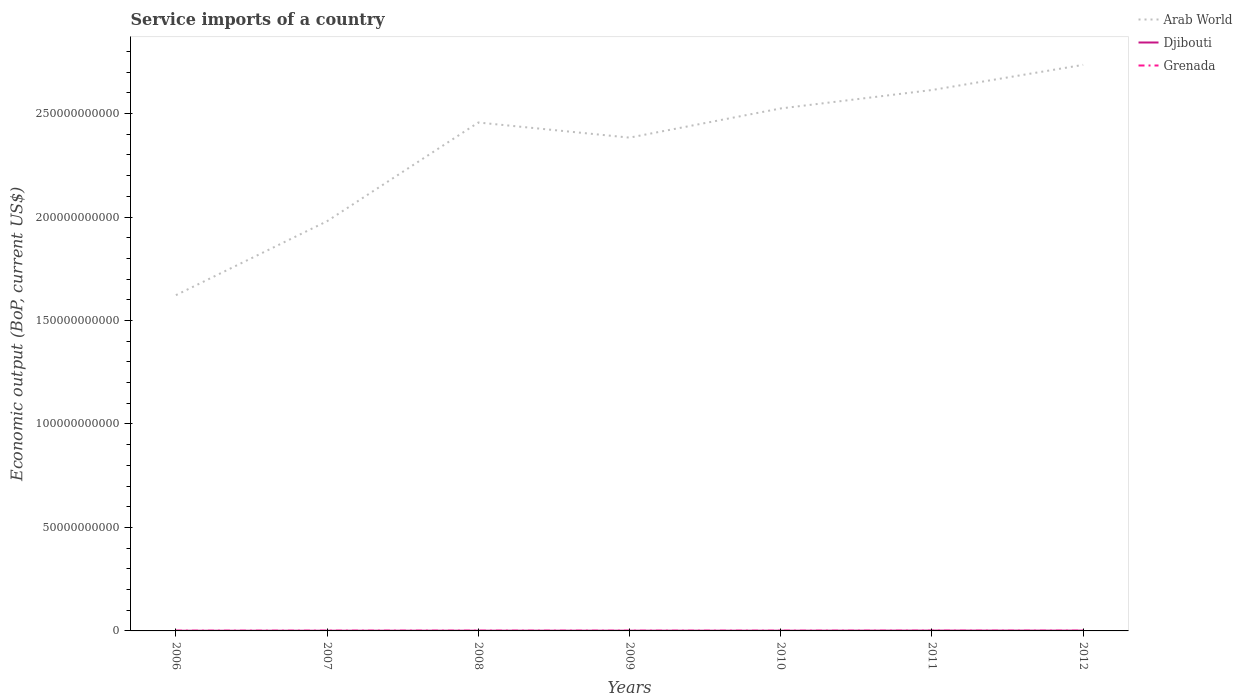Does the line corresponding to Arab World intersect with the line corresponding to Grenada?
Make the answer very short. No. Across all years, what is the maximum service imports in Arab World?
Provide a succinct answer. 1.62e+11. In which year was the service imports in Grenada maximum?
Ensure brevity in your answer.  2010. What is the total service imports in Grenada in the graph?
Keep it short and to the point. 1.04e+07. What is the difference between the highest and the second highest service imports in Grenada?
Your answer should be very brief. 1.90e+07. What is the difference between the highest and the lowest service imports in Djibouti?
Keep it short and to the point. 3. How many years are there in the graph?
Give a very brief answer. 7. Are the values on the major ticks of Y-axis written in scientific E-notation?
Give a very brief answer. No. What is the title of the graph?
Ensure brevity in your answer.  Service imports of a country. What is the label or title of the X-axis?
Offer a terse response. Years. What is the label or title of the Y-axis?
Provide a short and direct response. Economic output (BoP, current US$). What is the Economic output (BoP, current US$) in Arab World in 2006?
Your answer should be compact. 1.62e+11. What is the Economic output (BoP, current US$) of Djibouti in 2006?
Give a very brief answer. 8.93e+07. What is the Economic output (BoP, current US$) in Grenada in 2006?
Offer a terse response. 1.05e+08. What is the Economic output (BoP, current US$) in Arab World in 2007?
Make the answer very short. 1.98e+11. What is the Economic output (BoP, current US$) in Djibouti in 2007?
Make the answer very short. 9.54e+07. What is the Economic output (BoP, current US$) in Grenada in 2007?
Provide a succinct answer. 1.08e+08. What is the Economic output (BoP, current US$) of Arab World in 2008?
Your answer should be compact. 2.46e+11. What is the Economic output (BoP, current US$) in Djibouti in 2008?
Offer a very short reply. 1.17e+08. What is the Economic output (BoP, current US$) of Grenada in 2008?
Provide a succinct answer. 1.13e+08. What is the Economic output (BoP, current US$) of Arab World in 2009?
Offer a terse response. 2.38e+11. What is the Economic output (BoP, current US$) in Djibouti in 2009?
Your answer should be very brief. 1.14e+08. What is the Economic output (BoP, current US$) of Grenada in 2009?
Keep it short and to the point. 9.81e+07. What is the Economic output (BoP, current US$) of Arab World in 2010?
Provide a short and direct response. 2.52e+11. What is the Economic output (BoP, current US$) of Djibouti in 2010?
Your answer should be compact. 1.05e+08. What is the Economic output (BoP, current US$) in Grenada in 2010?
Offer a very short reply. 9.40e+07. What is the Economic output (BoP, current US$) in Arab World in 2011?
Your answer should be compact. 2.61e+11. What is the Economic output (BoP, current US$) in Djibouti in 2011?
Provide a succinct answer. 1.48e+08. What is the Economic output (BoP, current US$) in Grenada in 2011?
Offer a very short reply. 1.00e+08. What is the Economic output (BoP, current US$) in Arab World in 2012?
Your response must be concise. 2.74e+11. What is the Economic output (BoP, current US$) in Djibouti in 2012?
Make the answer very short. 1.45e+08. What is the Economic output (BoP, current US$) of Grenada in 2012?
Your answer should be compact. 9.54e+07. Across all years, what is the maximum Economic output (BoP, current US$) of Arab World?
Provide a short and direct response. 2.74e+11. Across all years, what is the maximum Economic output (BoP, current US$) in Djibouti?
Your answer should be compact. 1.48e+08. Across all years, what is the maximum Economic output (BoP, current US$) in Grenada?
Make the answer very short. 1.13e+08. Across all years, what is the minimum Economic output (BoP, current US$) in Arab World?
Offer a very short reply. 1.62e+11. Across all years, what is the minimum Economic output (BoP, current US$) in Djibouti?
Ensure brevity in your answer.  8.93e+07. Across all years, what is the minimum Economic output (BoP, current US$) in Grenada?
Make the answer very short. 9.40e+07. What is the total Economic output (BoP, current US$) in Arab World in the graph?
Make the answer very short. 1.63e+12. What is the total Economic output (BoP, current US$) in Djibouti in the graph?
Make the answer very short. 8.12e+08. What is the total Economic output (BoP, current US$) in Grenada in the graph?
Give a very brief answer. 7.14e+08. What is the difference between the Economic output (BoP, current US$) of Arab World in 2006 and that in 2007?
Keep it short and to the point. -3.57e+1. What is the difference between the Economic output (BoP, current US$) of Djibouti in 2006 and that in 2007?
Provide a succinct answer. -6.10e+06. What is the difference between the Economic output (BoP, current US$) of Grenada in 2006 and that in 2007?
Offer a terse response. -3.19e+06. What is the difference between the Economic output (BoP, current US$) of Arab World in 2006 and that in 2008?
Offer a terse response. -8.34e+1. What is the difference between the Economic output (BoP, current US$) in Djibouti in 2006 and that in 2008?
Your response must be concise. -2.72e+07. What is the difference between the Economic output (BoP, current US$) in Grenada in 2006 and that in 2008?
Give a very brief answer. -7.66e+06. What is the difference between the Economic output (BoP, current US$) in Arab World in 2006 and that in 2009?
Your response must be concise. -7.61e+1. What is the difference between the Economic output (BoP, current US$) in Djibouti in 2006 and that in 2009?
Keep it short and to the point. -2.47e+07. What is the difference between the Economic output (BoP, current US$) in Grenada in 2006 and that in 2009?
Provide a succinct answer. 7.21e+06. What is the difference between the Economic output (BoP, current US$) of Arab World in 2006 and that in 2010?
Give a very brief answer. -9.02e+1. What is the difference between the Economic output (BoP, current US$) in Djibouti in 2006 and that in 2010?
Offer a very short reply. -1.53e+07. What is the difference between the Economic output (BoP, current US$) in Grenada in 2006 and that in 2010?
Offer a very short reply. 1.13e+07. What is the difference between the Economic output (BoP, current US$) of Arab World in 2006 and that in 2011?
Ensure brevity in your answer.  -9.91e+1. What is the difference between the Economic output (BoP, current US$) of Djibouti in 2006 and that in 2011?
Make the answer very short. -5.85e+07. What is the difference between the Economic output (BoP, current US$) of Grenada in 2006 and that in 2011?
Make the answer very short. 5.11e+06. What is the difference between the Economic output (BoP, current US$) of Arab World in 2006 and that in 2012?
Your response must be concise. -1.11e+11. What is the difference between the Economic output (BoP, current US$) in Djibouti in 2006 and that in 2012?
Provide a succinct answer. -5.53e+07. What is the difference between the Economic output (BoP, current US$) of Grenada in 2006 and that in 2012?
Offer a very short reply. 9.94e+06. What is the difference between the Economic output (BoP, current US$) in Arab World in 2007 and that in 2008?
Your answer should be very brief. -4.77e+1. What is the difference between the Economic output (BoP, current US$) in Djibouti in 2007 and that in 2008?
Your answer should be very brief. -2.11e+07. What is the difference between the Economic output (BoP, current US$) of Grenada in 2007 and that in 2008?
Provide a succinct answer. -4.47e+06. What is the difference between the Economic output (BoP, current US$) in Arab World in 2007 and that in 2009?
Give a very brief answer. -4.04e+1. What is the difference between the Economic output (BoP, current US$) in Djibouti in 2007 and that in 2009?
Your answer should be compact. -1.86e+07. What is the difference between the Economic output (BoP, current US$) in Grenada in 2007 and that in 2009?
Your answer should be compact. 1.04e+07. What is the difference between the Economic output (BoP, current US$) in Arab World in 2007 and that in 2010?
Offer a terse response. -5.45e+1. What is the difference between the Economic output (BoP, current US$) of Djibouti in 2007 and that in 2010?
Offer a terse response. -9.17e+06. What is the difference between the Economic output (BoP, current US$) of Grenada in 2007 and that in 2010?
Offer a very short reply. 1.45e+07. What is the difference between the Economic output (BoP, current US$) of Arab World in 2007 and that in 2011?
Your answer should be very brief. -6.34e+1. What is the difference between the Economic output (BoP, current US$) in Djibouti in 2007 and that in 2011?
Your answer should be compact. -5.24e+07. What is the difference between the Economic output (BoP, current US$) of Grenada in 2007 and that in 2011?
Give a very brief answer. 8.30e+06. What is the difference between the Economic output (BoP, current US$) in Arab World in 2007 and that in 2012?
Your answer should be very brief. -7.55e+1. What is the difference between the Economic output (BoP, current US$) of Djibouti in 2007 and that in 2012?
Give a very brief answer. -4.92e+07. What is the difference between the Economic output (BoP, current US$) in Grenada in 2007 and that in 2012?
Ensure brevity in your answer.  1.31e+07. What is the difference between the Economic output (BoP, current US$) in Arab World in 2008 and that in 2009?
Your response must be concise. 7.30e+09. What is the difference between the Economic output (BoP, current US$) of Djibouti in 2008 and that in 2009?
Provide a short and direct response. 2.54e+06. What is the difference between the Economic output (BoP, current US$) in Grenada in 2008 and that in 2009?
Offer a terse response. 1.49e+07. What is the difference between the Economic output (BoP, current US$) in Arab World in 2008 and that in 2010?
Offer a very short reply. -6.80e+09. What is the difference between the Economic output (BoP, current US$) in Djibouti in 2008 and that in 2010?
Keep it short and to the point. 1.20e+07. What is the difference between the Economic output (BoP, current US$) in Grenada in 2008 and that in 2010?
Your answer should be compact. 1.90e+07. What is the difference between the Economic output (BoP, current US$) in Arab World in 2008 and that in 2011?
Keep it short and to the point. -1.57e+1. What is the difference between the Economic output (BoP, current US$) in Djibouti in 2008 and that in 2011?
Your answer should be very brief. -3.13e+07. What is the difference between the Economic output (BoP, current US$) of Grenada in 2008 and that in 2011?
Provide a short and direct response. 1.28e+07. What is the difference between the Economic output (BoP, current US$) of Arab World in 2008 and that in 2012?
Give a very brief answer. -2.79e+1. What is the difference between the Economic output (BoP, current US$) in Djibouti in 2008 and that in 2012?
Your answer should be compact. -2.81e+07. What is the difference between the Economic output (BoP, current US$) in Grenada in 2008 and that in 2012?
Your response must be concise. 1.76e+07. What is the difference between the Economic output (BoP, current US$) of Arab World in 2009 and that in 2010?
Offer a very short reply. -1.41e+1. What is the difference between the Economic output (BoP, current US$) of Djibouti in 2009 and that in 2010?
Ensure brevity in your answer.  9.42e+06. What is the difference between the Economic output (BoP, current US$) in Grenada in 2009 and that in 2010?
Give a very brief answer. 4.11e+06. What is the difference between the Economic output (BoP, current US$) in Arab World in 2009 and that in 2011?
Provide a succinct answer. -2.30e+1. What is the difference between the Economic output (BoP, current US$) of Djibouti in 2009 and that in 2011?
Ensure brevity in your answer.  -3.38e+07. What is the difference between the Economic output (BoP, current US$) of Grenada in 2009 and that in 2011?
Your answer should be compact. -2.10e+06. What is the difference between the Economic output (BoP, current US$) in Arab World in 2009 and that in 2012?
Your answer should be very brief. -3.52e+1. What is the difference between the Economic output (BoP, current US$) in Djibouti in 2009 and that in 2012?
Provide a succinct answer. -3.06e+07. What is the difference between the Economic output (BoP, current US$) of Grenada in 2009 and that in 2012?
Offer a terse response. 2.73e+06. What is the difference between the Economic output (BoP, current US$) in Arab World in 2010 and that in 2011?
Your answer should be compact. -8.90e+09. What is the difference between the Economic output (BoP, current US$) in Djibouti in 2010 and that in 2011?
Provide a succinct answer. -4.32e+07. What is the difference between the Economic output (BoP, current US$) in Grenada in 2010 and that in 2011?
Make the answer very short. -6.20e+06. What is the difference between the Economic output (BoP, current US$) in Arab World in 2010 and that in 2012?
Ensure brevity in your answer.  -2.11e+1. What is the difference between the Economic output (BoP, current US$) of Djibouti in 2010 and that in 2012?
Offer a terse response. -4.01e+07. What is the difference between the Economic output (BoP, current US$) of Grenada in 2010 and that in 2012?
Offer a terse response. -1.37e+06. What is the difference between the Economic output (BoP, current US$) of Arab World in 2011 and that in 2012?
Provide a short and direct response. -1.22e+1. What is the difference between the Economic output (BoP, current US$) of Djibouti in 2011 and that in 2012?
Your answer should be compact. 3.16e+06. What is the difference between the Economic output (BoP, current US$) in Grenada in 2011 and that in 2012?
Give a very brief answer. 4.83e+06. What is the difference between the Economic output (BoP, current US$) of Arab World in 2006 and the Economic output (BoP, current US$) of Djibouti in 2007?
Ensure brevity in your answer.  1.62e+11. What is the difference between the Economic output (BoP, current US$) of Arab World in 2006 and the Economic output (BoP, current US$) of Grenada in 2007?
Offer a very short reply. 1.62e+11. What is the difference between the Economic output (BoP, current US$) of Djibouti in 2006 and the Economic output (BoP, current US$) of Grenada in 2007?
Give a very brief answer. -1.92e+07. What is the difference between the Economic output (BoP, current US$) in Arab World in 2006 and the Economic output (BoP, current US$) in Djibouti in 2008?
Give a very brief answer. 1.62e+11. What is the difference between the Economic output (BoP, current US$) of Arab World in 2006 and the Economic output (BoP, current US$) of Grenada in 2008?
Offer a terse response. 1.62e+11. What is the difference between the Economic output (BoP, current US$) in Djibouti in 2006 and the Economic output (BoP, current US$) in Grenada in 2008?
Make the answer very short. -2.37e+07. What is the difference between the Economic output (BoP, current US$) of Arab World in 2006 and the Economic output (BoP, current US$) of Djibouti in 2009?
Keep it short and to the point. 1.62e+11. What is the difference between the Economic output (BoP, current US$) of Arab World in 2006 and the Economic output (BoP, current US$) of Grenada in 2009?
Provide a succinct answer. 1.62e+11. What is the difference between the Economic output (BoP, current US$) in Djibouti in 2006 and the Economic output (BoP, current US$) in Grenada in 2009?
Your answer should be compact. -8.83e+06. What is the difference between the Economic output (BoP, current US$) of Arab World in 2006 and the Economic output (BoP, current US$) of Djibouti in 2010?
Offer a terse response. 1.62e+11. What is the difference between the Economic output (BoP, current US$) of Arab World in 2006 and the Economic output (BoP, current US$) of Grenada in 2010?
Offer a very short reply. 1.62e+11. What is the difference between the Economic output (BoP, current US$) in Djibouti in 2006 and the Economic output (BoP, current US$) in Grenada in 2010?
Your response must be concise. -4.73e+06. What is the difference between the Economic output (BoP, current US$) in Arab World in 2006 and the Economic output (BoP, current US$) in Djibouti in 2011?
Offer a very short reply. 1.62e+11. What is the difference between the Economic output (BoP, current US$) in Arab World in 2006 and the Economic output (BoP, current US$) in Grenada in 2011?
Your answer should be very brief. 1.62e+11. What is the difference between the Economic output (BoP, current US$) of Djibouti in 2006 and the Economic output (BoP, current US$) of Grenada in 2011?
Your answer should be compact. -1.09e+07. What is the difference between the Economic output (BoP, current US$) in Arab World in 2006 and the Economic output (BoP, current US$) in Djibouti in 2012?
Keep it short and to the point. 1.62e+11. What is the difference between the Economic output (BoP, current US$) in Arab World in 2006 and the Economic output (BoP, current US$) in Grenada in 2012?
Ensure brevity in your answer.  1.62e+11. What is the difference between the Economic output (BoP, current US$) in Djibouti in 2006 and the Economic output (BoP, current US$) in Grenada in 2012?
Your response must be concise. -6.10e+06. What is the difference between the Economic output (BoP, current US$) of Arab World in 2007 and the Economic output (BoP, current US$) of Djibouti in 2008?
Your answer should be very brief. 1.98e+11. What is the difference between the Economic output (BoP, current US$) in Arab World in 2007 and the Economic output (BoP, current US$) in Grenada in 2008?
Your answer should be very brief. 1.98e+11. What is the difference between the Economic output (BoP, current US$) of Djibouti in 2007 and the Economic output (BoP, current US$) of Grenada in 2008?
Provide a short and direct response. -1.76e+07. What is the difference between the Economic output (BoP, current US$) in Arab World in 2007 and the Economic output (BoP, current US$) in Djibouti in 2009?
Give a very brief answer. 1.98e+11. What is the difference between the Economic output (BoP, current US$) of Arab World in 2007 and the Economic output (BoP, current US$) of Grenada in 2009?
Provide a short and direct response. 1.98e+11. What is the difference between the Economic output (BoP, current US$) of Djibouti in 2007 and the Economic output (BoP, current US$) of Grenada in 2009?
Your answer should be compact. -2.73e+06. What is the difference between the Economic output (BoP, current US$) of Arab World in 2007 and the Economic output (BoP, current US$) of Djibouti in 2010?
Your answer should be very brief. 1.98e+11. What is the difference between the Economic output (BoP, current US$) in Arab World in 2007 and the Economic output (BoP, current US$) in Grenada in 2010?
Your response must be concise. 1.98e+11. What is the difference between the Economic output (BoP, current US$) of Djibouti in 2007 and the Economic output (BoP, current US$) of Grenada in 2010?
Make the answer very short. 1.37e+06. What is the difference between the Economic output (BoP, current US$) of Arab World in 2007 and the Economic output (BoP, current US$) of Djibouti in 2011?
Provide a succinct answer. 1.98e+11. What is the difference between the Economic output (BoP, current US$) in Arab World in 2007 and the Economic output (BoP, current US$) in Grenada in 2011?
Give a very brief answer. 1.98e+11. What is the difference between the Economic output (BoP, current US$) in Djibouti in 2007 and the Economic output (BoP, current US$) in Grenada in 2011?
Your response must be concise. -4.83e+06. What is the difference between the Economic output (BoP, current US$) in Arab World in 2007 and the Economic output (BoP, current US$) in Djibouti in 2012?
Your answer should be compact. 1.98e+11. What is the difference between the Economic output (BoP, current US$) of Arab World in 2007 and the Economic output (BoP, current US$) of Grenada in 2012?
Provide a short and direct response. 1.98e+11. What is the difference between the Economic output (BoP, current US$) in Djibouti in 2007 and the Economic output (BoP, current US$) in Grenada in 2012?
Ensure brevity in your answer.  -445.55. What is the difference between the Economic output (BoP, current US$) of Arab World in 2008 and the Economic output (BoP, current US$) of Djibouti in 2009?
Offer a terse response. 2.46e+11. What is the difference between the Economic output (BoP, current US$) in Arab World in 2008 and the Economic output (BoP, current US$) in Grenada in 2009?
Offer a terse response. 2.46e+11. What is the difference between the Economic output (BoP, current US$) of Djibouti in 2008 and the Economic output (BoP, current US$) of Grenada in 2009?
Offer a very short reply. 1.84e+07. What is the difference between the Economic output (BoP, current US$) of Arab World in 2008 and the Economic output (BoP, current US$) of Djibouti in 2010?
Make the answer very short. 2.46e+11. What is the difference between the Economic output (BoP, current US$) of Arab World in 2008 and the Economic output (BoP, current US$) of Grenada in 2010?
Offer a terse response. 2.46e+11. What is the difference between the Economic output (BoP, current US$) of Djibouti in 2008 and the Economic output (BoP, current US$) of Grenada in 2010?
Your answer should be compact. 2.25e+07. What is the difference between the Economic output (BoP, current US$) of Arab World in 2008 and the Economic output (BoP, current US$) of Djibouti in 2011?
Your answer should be compact. 2.46e+11. What is the difference between the Economic output (BoP, current US$) in Arab World in 2008 and the Economic output (BoP, current US$) in Grenada in 2011?
Offer a terse response. 2.46e+11. What is the difference between the Economic output (BoP, current US$) of Djibouti in 2008 and the Economic output (BoP, current US$) of Grenada in 2011?
Ensure brevity in your answer.  1.63e+07. What is the difference between the Economic output (BoP, current US$) in Arab World in 2008 and the Economic output (BoP, current US$) in Djibouti in 2012?
Offer a very short reply. 2.46e+11. What is the difference between the Economic output (BoP, current US$) of Arab World in 2008 and the Economic output (BoP, current US$) of Grenada in 2012?
Your answer should be very brief. 2.46e+11. What is the difference between the Economic output (BoP, current US$) in Djibouti in 2008 and the Economic output (BoP, current US$) in Grenada in 2012?
Your answer should be very brief. 2.11e+07. What is the difference between the Economic output (BoP, current US$) of Arab World in 2009 and the Economic output (BoP, current US$) of Djibouti in 2010?
Provide a succinct answer. 2.38e+11. What is the difference between the Economic output (BoP, current US$) in Arab World in 2009 and the Economic output (BoP, current US$) in Grenada in 2010?
Your answer should be compact. 2.38e+11. What is the difference between the Economic output (BoP, current US$) in Djibouti in 2009 and the Economic output (BoP, current US$) in Grenada in 2010?
Give a very brief answer. 2.00e+07. What is the difference between the Economic output (BoP, current US$) of Arab World in 2009 and the Economic output (BoP, current US$) of Djibouti in 2011?
Make the answer very short. 2.38e+11. What is the difference between the Economic output (BoP, current US$) of Arab World in 2009 and the Economic output (BoP, current US$) of Grenada in 2011?
Provide a succinct answer. 2.38e+11. What is the difference between the Economic output (BoP, current US$) in Djibouti in 2009 and the Economic output (BoP, current US$) in Grenada in 2011?
Your answer should be compact. 1.38e+07. What is the difference between the Economic output (BoP, current US$) in Arab World in 2009 and the Economic output (BoP, current US$) in Djibouti in 2012?
Keep it short and to the point. 2.38e+11. What is the difference between the Economic output (BoP, current US$) in Arab World in 2009 and the Economic output (BoP, current US$) in Grenada in 2012?
Your answer should be compact. 2.38e+11. What is the difference between the Economic output (BoP, current US$) in Djibouti in 2009 and the Economic output (BoP, current US$) in Grenada in 2012?
Offer a very short reply. 1.86e+07. What is the difference between the Economic output (BoP, current US$) in Arab World in 2010 and the Economic output (BoP, current US$) in Djibouti in 2011?
Your response must be concise. 2.52e+11. What is the difference between the Economic output (BoP, current US$) of Arab World in 2010 and the Economic output (BoP, current US$) of Grenada in 2011?
Offer a very short reply. 2.52e+11. What is the difference between the Economic output (BoP, current US$) of Djibouti in 2010 and the Economic output (BoP, current US$) of Grenada in 2011?
Provide a succinct answer. 4.34e+06. What is the difference between the Economic output (BoP, current US$) of Arab World in 2010 and the Economic output (BoP, current US$) of Djibouti in 2012?
Provide a short and direct response. 2.52e+11. What is the difference between the Economic output (BoP, current US$) in Arab World in 2010 and the Economic output (BoP, current US$) in Grenada in 2012?
Your response must be concise. 2.52e+11. What is the difference between the Economic output (BoP, current US$) of Djibouti in 2010 and the Economic output (BoP, current US$) of Grenada in 2012?
Your response must be concise. 9.17e+06. What is the difference between the Economic output (BoP, current US$) of Arab World in 2011 and the Economic output (BoP, current US$) of Djibouti in 2012?
Keep it short and to the point. 2.61e+11. What is the difference between the Economic output (BoP, current US$) in Arab World in 2011 and the Economic output (BoP, current US$) in Grenada in 2012?
Ensure brevity in your answer.  2.61e+11. What is the difference between the Economic output (BoP, current US$) of Djibouti in 2011 and the Economic output (BoP, current US$) of Grenada in 2012?
Ensure brevity in your answer.  5.24e+07. What is the average Economic output (BoP, current US$) in Arab World per year?
Offer a terse response. 2.33e+11. What is the average Economic output (BoP, current US$) in Djibouti per year?
Offer a terse response. 1.16e+08. What is the average Economic output (BoP, current US$) in Grenada per year?
Your answer should be very brief. 1.02e+08. In the year 2006, what is the difference between the Economic output (BoP, current US$) in Arab World and Economic output (BoP, current US$) in Djibouti?
Give a very brief answer. 1.62e+11. In the year 2006, what is the difference between the Economic output (BoP, current US$) of Arab World and Economic output (BoP, current US$) of Grenada?
Offer a very short reply. 1.62e+11. In the year 2006, what is the difference between the Economic output (BoP, current US$) in Djibouti and Economic output (BoP, current US$) in Grenada?
Ensure brevity in your answer.  -1.60e+07. In the year 2007, what is the difference between the Economic output (BoP, current US$) of Arab World and Economic output (BoP, current US$) of Djibouti?
Offer a terse response. 1.98e+11. In the year 2007, what is the difference between the Economic output (BoP, current US$) in Arab World and Economic output (BoP, current US$) in Grenada?
Provide a short and direct response. 1.98e+11. In the year 2007, what is the difference between the Economic output (BoP, current US$) of Djibouti and Economic output (BoP, current US$) of Grenada?
Provide a short and direct response. -1.31e+07. In the year 2008, what is the difference between the Economic output (BoP, current US$) in Arab World and Economic output (BoP, current US$) in Djibouti?
Provide a short and direct response. 2.46e+11. In the year 2008, what is the difference between the Economic output (BoP, current US$) in Arab World and Economic output (BoP, current US$) in Grenada?
Your answer should be very brief. 2.46e+11. In the year 2008, what is the difference between the Economic output (BoP, current US$) in Djibouti and Economic output (BoP, current US$) in Grenada?
Give a very brief answer. 3.54e+06. In the year 2009, what is the difference between the Economic output (BoP, current US$) of Arab World and Economic output (BoP, current US$) of Djibouti?
Give a very brief answer. 2.38e+11. In the year 2009, what is the difference between the Economic output (BoP, current US$) of Arab World and Economic output (BoP, current US$) of Grenada?
Your response must be concise. 2.38e+11. In the year 2009, what is the difference between the Economic output (BoP, current US$) in Djibouti and Economic output (BoP, current US$) in Grenada?
Make the answer very short. 1.59e+07. In the year 2010, what is the difference between the Economic output (BoP, current US$) of Arab World and Economic output (BoP, current US$) of Djibouti?
Your answer should be compact. 2.52e+11. In the year 2010, what is the difference between the Economic output (BoP, current US$) in Arab World and Economic output (BoP, current US$) in Grenada?
Offer a terse response. 2.52e+11. In the year 2010, what is the difference between the Economic output (BoP, current US$) of Djibouti and Economic output (BoP, current US$) of Grenada?
Offer a very short reply. 1.05e+07. In the year 2011, what is the difference between the Economic output (BoP, current US$) in Arab World and Economic output (BoP, current US$) in Djibouti?
Ensure brevity in your answer.  2.61e+11. In the year 2011, what is the difference between the Economic output (BoP, current US$) of Arab World and Economic output (BoP, current US$) of Grenada?
Your answer should be compact. 2.61e+11. In the year 2011, what is the difference between the Economic output (BoP, current US$) of Djibouti and Economic output (BoP, current US$) of Grenada?
Offer a very short reply. 4.76e+07. In the year 2012, what is the difference between the Economic output (BoP, current US$) in Arab World and Economic output (BoP, current US$) in Djibouti?
Keep it short and to the point. 2.73e+11. In the year 2012, what is the difference between the Economic output (BoP, current US$) in Arab World and Economic output (BoP, current US$) in Grenada?
Your answer should be compact. 2.73e+11. In the year 2012, what is the difference between the Economic output (BoP, current US$) of Djibouti and Economic output (BoP, current US$) of Grenada?
Your answer should be very brief. 4.92e+07. What is the ratio of the Economic output (BoP, current US$) in Arab World in 2006 to that in 2007?
Your response must be concise. 0.82. What is the ratio of the Economic output (BoP, current US$) of Djibouti in 2006 to that in 2007?
Ensure brevity in your answer.  0.94. What is the ratio of the Economic output (BoP, current US$) of Grenada in 2006 to that in 2007?
Give a very brief answer. 0.97. What is the ratio of the Economic output (BoP, current US$) of Arab World in 2006 to that in 2008?
Keep it short and to the point. 0.66. What is the ratio of the Economic output (BoP, current US$) of Djibouti in 2006 to that in 2008?
Provide a succinct answer. 0.77. What is the ratio of the Economic output (BoP, current US$) of Grenada in 2006 to that in 2008?
Your response must be concise. 0.93. What is the ratio of the Economic output (BoP, current US$) of Arab World in 2006 to that in 2009?
Your response must be concise. 0.68. What is the ratio of the Economic output (BoP, current US$) in Djibouti in 2006 to that in 2009?
Your answer should be very brief. 0.78. What is the ratio of the Economic output (BoP, current US$) of Grenada in 2006 to that in 2009?
Ensure brevity in your answer.  1.07. What is the ratio of the Economic output (BoP, current US$) in Arab World in 2006 to that in 2010?
Ensure brevity in your answer.  0.64. What is the ratio of the Economic output (BoP, current US$) of Djibouti in 2006 to that in 2010?
Offer a terse response. 0.85. What is the ratio of the Economic output (BoP, current US$) of Grenada in 2006 to that in 2010?
Give a very brief answer. 1.12. What is the ratio of the Economic output (BoP, current US$) of Arab World in 2006 to that in 2011?
Keep it short and to the point. 0.62. What is the ratio of the Economic output (BoP, current US$) of Djibouti in 2006 to that in 2011?
Ensure brevity in your answer.  0.6. What is the ratio of the Economic output (BoP, current US$) in Grenada in 2006 to that in 2011?
Give a very brief answer. 1.05. What is the ratio of the Economic output (BoP, current US$) of Arab World in 2006 to that in 2012?
Your response must be concise. 0.59. What is the ratio of the Economic output (BoP, current US$) in Djibouti in 2006 to that in 2012?
Your answer should be compact. 0.62. What is the ratio of the Economic output (BoP, current US$) of Grenada in 2006 to that in 2012?
Your response must be concise. 1.1. What is the ratio of the Economic output (BoP, current US$) in Arab World in 2007 to that in 2008?
Keep it short and to the point. 0.81. What is the ratio of the Economic output (BoP, current US$) in Djibouti in 2007 to that in 2008?
Your answer should be compact. 0.82. What is the ratio of the Economic output (BoP, current US$) in Grenada in 2007 to that in 2008?
Your answer should be very brief. 0.96. What is the ratio of the Economic output (BoP, current US$) of Arab World in 2007 to that in 2009?
Offer a very short reply. 0.83. What is the ratio of the Economic output (BoP, current US$) in Djibouti in 2007 to that in 2009?
Provide a short and direct response. 0.84. What is the ratio of the Economic output (BoP, current US$) of Grenada in 2007 to that in 2009?
Your answer should be very brief. 1.11. What is the ratio of the Economic output (BoP, current US$) in Arab World in 2007 to that in 2010?
Your answer should be compact. 0.78. What is the ratio of the Economic output (BoP, current US$) of Djibouti in 2007 to that in 2010?
Your answer should be very brief. 0.91. What is the ratio of the Economic output (BoP, current US$) of Grenada in 2007 to that in 2010?
Provide a succinct answer. 1.15. What is the ratio of the Economic output (BoP, current US$) in Arab World in 2007 to that in 2011?
Provide a succinct answer. 0.76. What is the ratio of the Economic output (BoP, current US$) of Djibouti in 2007 to that in 2011?
Offer a terse response. 0.65. What is the ratio of the Economic output (BoP, current US$) in Grenada in 2007 to that in 2011?
Your response must be concise. 1.08. What is the ratio of the Economic output (BoP, current US$) in Arab World in 2007 to that in 2012?
Offer a terse response. 0.72. What is the ratio of the Economic output (BoP, current US$) in Djibouti in 2007 to that in 2012?
Keep it short and to the point. 0.66. What is the ratio of the Economic output (BoP, current US$) in Grenada in 2007 to that in 2012?
Provide a succinct answer. 1.14. What is the ratio of the Economic output (BoP, current US$) in Arab World in 2008 to that in 2009?
Offer a terse response. 1.03. What is the ratio of the Economic output (BoP, current US$) in Djibouti in 2008 to that in 2009?
Your answer should be very brief. 1.02. What is the ratio of the Economic output (BoP, current US$) of Grenada in 2008 to that in 2009?
Provide a short and direct response. 1.15. What is the ratio of the Economic output (BoP, current US$) of Arab World in 2008 to that in 2010?
Your response must be concise. 0.97. What is the ratio of the Economic output (BoP, current US$) in Djibouti in 2008 to that in 2010?
Your response must be concise. 1.11. What is the ratio of the Economic output (BoP, current US$) in Grenada in 2008 to that in 2010?
Your response must be concise. 1.2. What is the ratio of the Economic output (BoP, current US$) of Arab World in 2008 to that in 2011?
Provide a succinct answer. 0.94. What is the ratio of the Economic output (BoP, current US$) in Djibouti in 2008 to that in 2011?
Make the answer very short. 0.79. What is the ratio of the Economic output (BoP, current US$) of Grenada in 2008 to that in 2011?
Keep it short and to the point. 1.13. What is the ratio of the Economic output (BoP, current US$) of Arab World in 2008 to that in 2012?
Offer a very short reply. 0.9. What is the ratio of the Economic output (BoP, current US$) of Djibouti in 2008 to that in 2012?
Make the answer very short. 0.81. What is the ratio of the Economic output (BoP, current US$) in Grenada in 2008 to that in 2012?
Provide a succinct answer. 1.18. What is the ratio of the Economic output (BoP, current US$) in Arab World in 2009 to that in 2010?
Make the answer very short. 0.94. What is the ratio of the Economic output (BoP, current US$) in Djibouti in 2009 to that in 2010?
Your answer should be very brief. 1.09. What is the ratio of the Economic output (BoP, current US$) in Grenada in 2009 to that in 2010?
Offer a terse response. 1.04. What is the ratio of the Economic output (BoP, current US$) of Arab World in 2009 to that in 2011?
Offer a terse response. 0.91. What is the ratio of the Economic output (BoP, current US$) of Djibouti in 2009 to that in 2011?
Keep it short and to the point. 0.77. What is the ratio of the Economic output (BoP, current US$) in Grenada in 2009 to that in 2011?
Your answer should be compact. 0.98. What is the ratio of the Economic output (BoP, current US$) of Arab World in 2009 to that in 2012?
Offer a terse response. 0.87. What is the ratio of the Economic output (BoP, current US$) in Djibouti in 2009 to that in 2012?
Your answer should be compact. 0.79. What is the ratio of the Economic output (BoP, current US$) in Grenada in 2009 to that in 2012?
Ensure brevity in your answer.  1.03. What is the ratio of the Economic output (BoP, current US$) of Arab World in 2010 to that in 2011?
Provide a succinct answer. 0.97. What is the ratio of the Economic output (BoP, current US$) of Djibouti in 2010 to that in 2011?
Offer a very short reply. 0.71. What is the ratio of the Economic output (BoP, current US$) in Grenada in 2010 to that in 2011?
Ensure brevity in your answer.  0.94. What is the ratio of the Economic output (BoP, current US$) in Arab World in 2010 to that in 2012?
Your answer should be very brief. 0.92. What is the ratio of the Economic output (BoP, current US$) in Djibouti in 2010 to that in 2012?
Ensure brevity in your answer.  0.72. What is the ratio of the Economic output (BoP, current US$) of Grenada in 2010 to that in 2012?
Offer a very short reply. 0.99. What is the ratio of the Economic output (BoP, current US$) in Arab World in 2011 to that in 2012?
Offer a terse response. 0.96. What is the ratio of the Economic output (BoP, current US$) of Djibouti in 2011 to that in 2012?
Make the answer very short. 1.02. What is the ratio of the Economic output (BoP, current US$) of Grenada in 2011 to that in 2012?
Provide a succinct answer. 1.05. What is the difference between the highest and the second highest Economic output (BoP, current US$) of Arab World?
Give a very brief answer. 1.22e+1. What is the difference between the highest and the second highest Economic output (BoP, current US$) in Djibouti?
Your response must be concise. 3.16e+06. What is the difference between the highest and the second highest Economic output (BoP, current US$) in Grenada?
Offer a very short reply. 4.47e+06. What is the difference between the highest and the lowest Economic output (BoP, current US$) of Arab World?
Provide a short and direct response. 1.11e+11. What is the difference between the highest and the lowest Economic output (BoP, current US$) of Djibouti?
Give a very brief answer. 5.85e+07. What is the difference between the highest and the lowest Economic output (BoP, current US$) in Grenada?
Your answer should be very brief. 1.90e+07. 